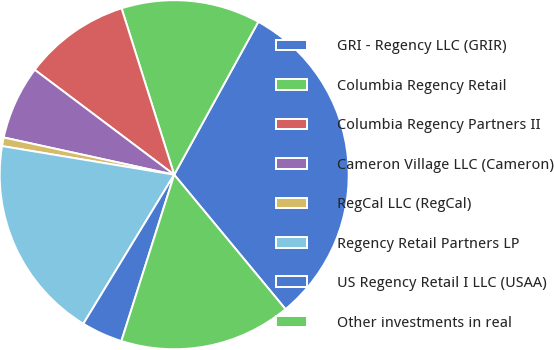Convert chart to OTSL. <chart><loc_0><loc_0><loc_500><loc_500><pie_chart><fcel>GRI - Regency LLC (GRIR)<fcel>Columbia Regency Retail<fcel>Columbia Regency Partners II<fcel>Cameron Village LLC (Cameron)<fcel>RegCal LLC (RegCal)<fcel>Regency Retail Partners LP<fcel>US Regency Retail I LLC (USAA)<fcel>Other investments in real<nl><fcel>30.99%<fcel>12.88%<fcel>9.86%<fcel>6.84%<fcel>0.8%<fcel>18.91%<fcel>3.82%<fcel>15.9%<nl></chart> 